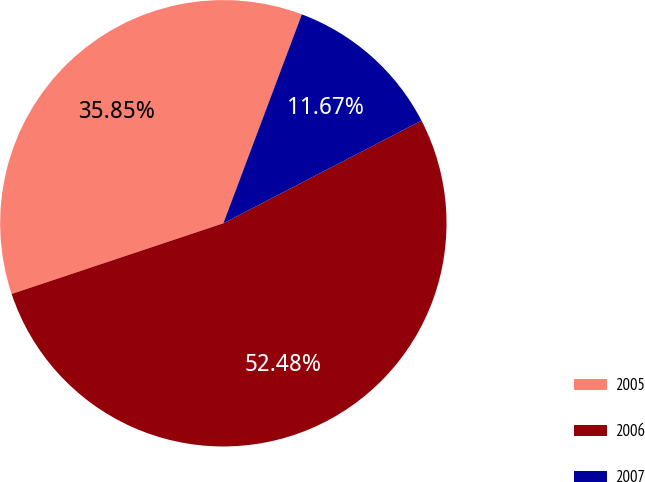<chart> <loc_0><loc_0><loc_500><loc_500><pie_chart><fcel>2005<fcel>2006<fcel>2007<nl><fcel>35.85%<fcel>52.48%<fcel>11.67%<nl></chart> 